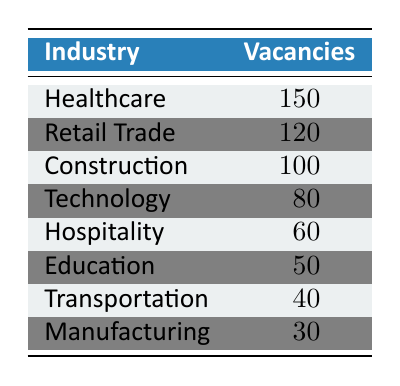What industry has the highest number of job vacancies? In the table, Healthcare has 150 vacancies, which is the highest compared to the other industries listed.
Answer: Healthcare How many job vacancies are there in Retail Trade? The table states that the number of job vacancies in Retail Trade is 120.
Answer: 120 Which industry has the least number of job vacancies? By looking at the table, Manufacturing has the least vacancies with only 30, making it the lowest.
Answer: Manufacturing What is the total number of job vacancies in the Technology and Hospitality industries combined? To find the total, we add the vacancies: Technology (80) + Hospitality (60) = 140.
Answer: 140 Is the number of job vacancies in Education greater than those in Transportation? The table shows Education has 50 vacancies and Transportation has 40 vacancies, thus Education has more vacancies.
Answer: Yes What is the average number of job vacancies across all industries listed? To calculate the average, sum all vacancies: 150 + 120 + 100 + 80 + 60 + 50 + 40 + 30 = 630. There are 8 industries, so the average is 630/8 = 78.75.
Answer: 78.75 How many more job vacancies does Healthcare have compared to Manufacturing? The difference is calculated by subtracting Manufacturing vacancies from Healthcare vacancies: 150 - 30 = 120.
Answer: 120 Which industry has more than 100 job vacancies? From the table, Healthcare (150), Retail Trade (120), and Construction (100) have more than 100 vacancies.
Answer: Healthcare, Retail Trade, Construction If you combine the vacancies in Construction and Education, how does it compare to Transportation? First, add Construction (100) and Education (50) to get 150. Transportation has 40 vacancies. Since 150 > 40, the combined total is greater than Transportation.
Answer: Greater than 